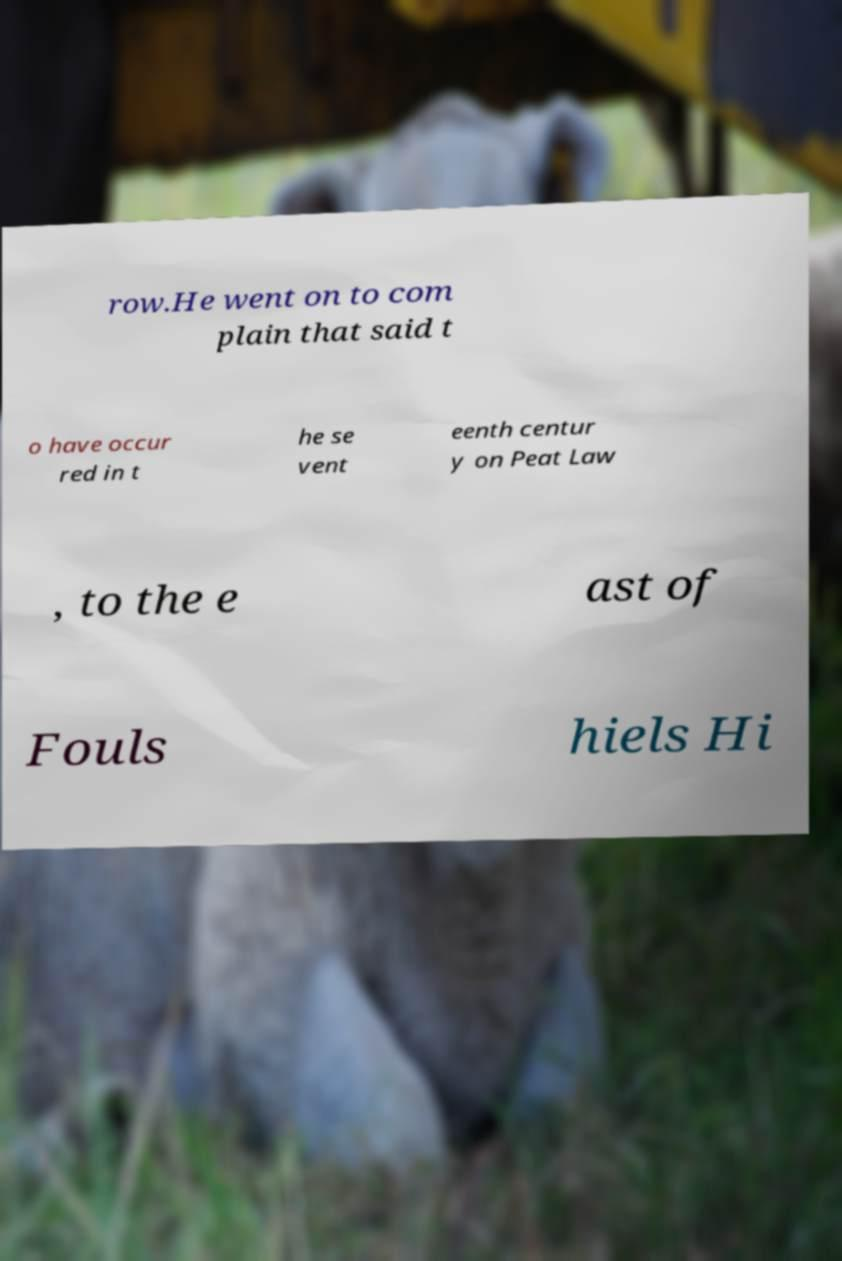I need the written content from this picture converted into text. Can you do that? row.He went on to com plain that said t o have occur red in t he se vent eenth centur y on Peat Law , to the e ast of Fouls hiels Hi 